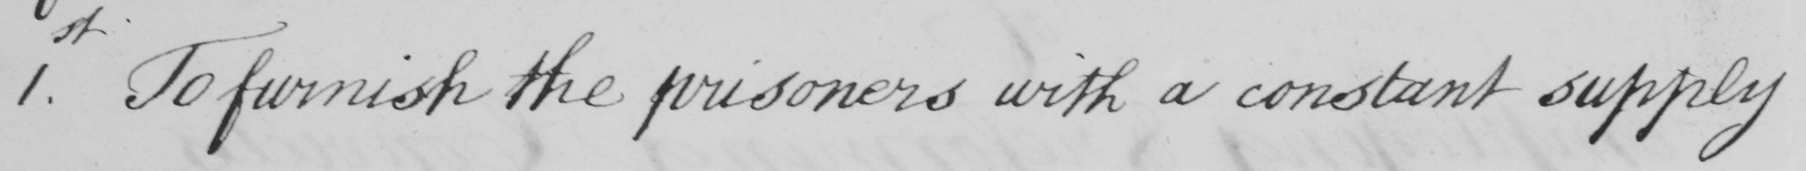Can you read and transcribe this handwriting? 1st. To furnish the prisoners with a constant supply 